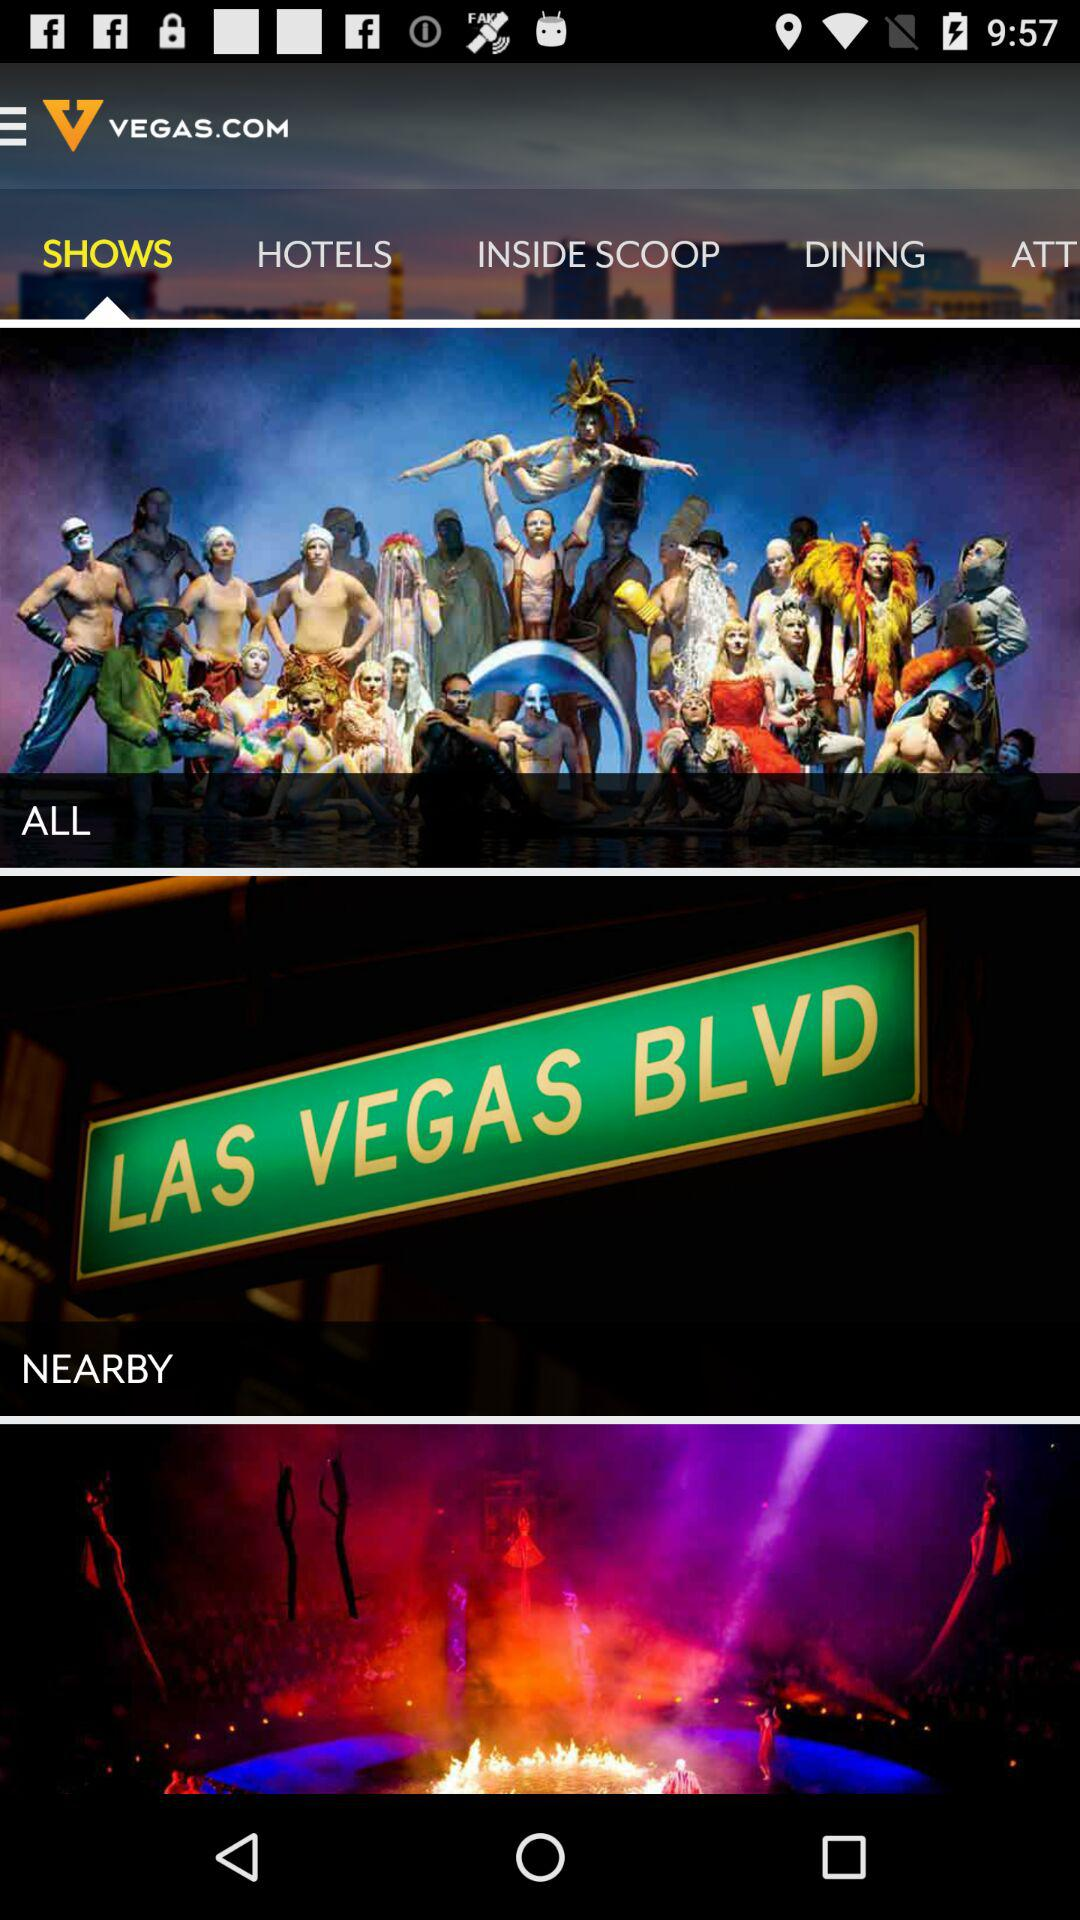What is the application name? The application name is "VEGAS.COM". 